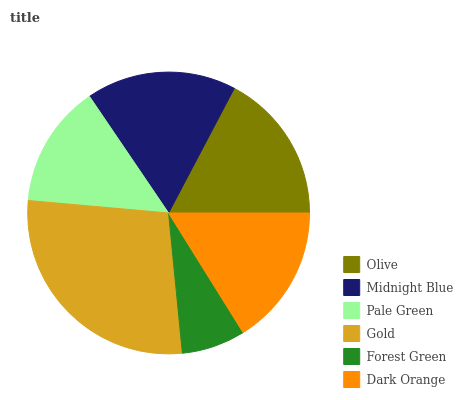Is Forest Green the minimum?
Answer yes or no. Yes. Is Gold the maximum?
Answer yes or no. Yes. Is Midnight Blue the minimum?
Answer yes or no. No. Is Midnight Blue the maximum?
Answer yes or no. No. Is Olive greater than Midnight Blue?
Answer yes or no. Yes. Is Midnight Blue less than Olive?
Answer yes or no. Yes. Is Midnight Blue greater than Olive?
Answer yes or no. No. Is Olive less than Midnight Blue?
Answer yes or no. No. Is Midnight Blue the high median?
Answer yes or no. Yes. Is Dark Orange the low median?
Answer yes or no. Yes. Is Pale Green the high median?
Answer yes or no. No. Is Gold the low median?
Answer yes or no. No. 